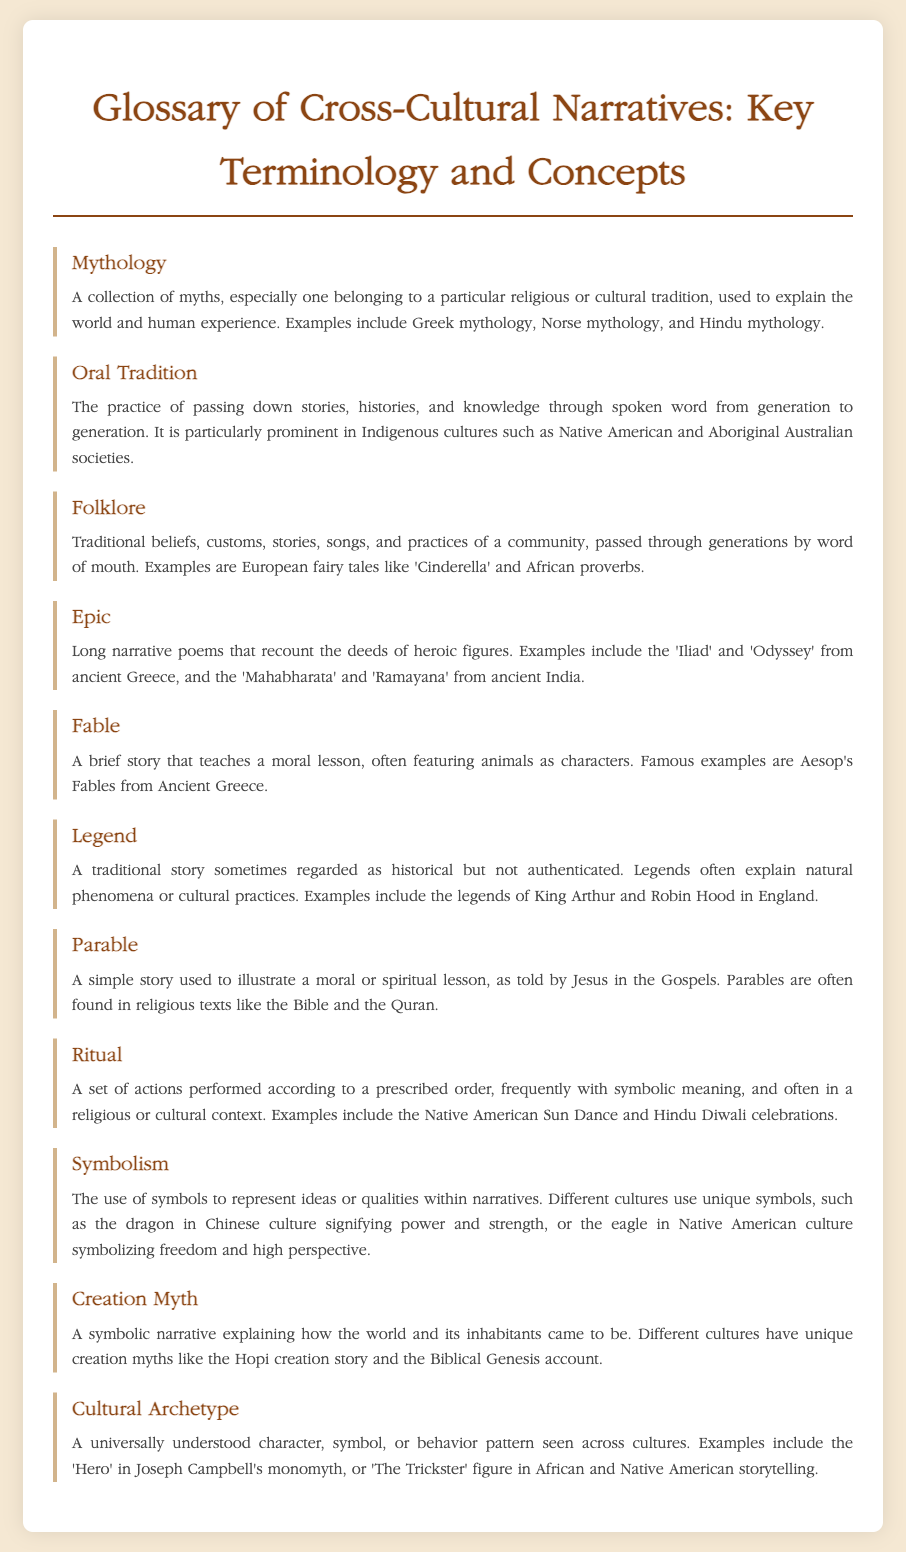What is a collection of myths? A collection of myths is used to explain the world and human experience, belonging to a particular religious or cultural tradition.
Answer: Mythology What practice involves passing down stories through spoken word? This practice is primarily seen in Indigenous cultures and involves oral storytelling from generation to generation.
Answer: Oral Tradition What are traditional beliefs and stories passed by word of mouth called? These are traditional beliefs, customs, stories, songs, and practices of a community that are shared orally.
Answer: Folklore Which narrative form features heroic figures and is often a long poem? This narrative form recounts the deeds of heroic figures through a long narrative format, often in poetic form.
Answer: Epic What type of story often features animals and teaches a moral lesson? This type of story is typically brief and aims to convey moral lessons through the actions of animals.
Answer: Fable What is a traditional story that may not be authenticated but explains cultural practices? This type of story is sometimes regarded as historical and often explains natural phenomena or cultural practices.
Answer: Legend What story format is used to illustrate a moral or spiritual lesson? This format is often found in religious texts and utilizes stories that simplify moral concepts.
Answer: Parable What is a set of actions with symbolic meaning performed in a cultural context? This refers to a customary practice that often has a deeper significance within a culture or religion.
Answer: Ritual What term refers to the use of symbols to represent ideas within narratives? This term describes how different cultures utilize symbols, such as animals or natural elements, to convey deeper meanings.
Answer: Symbolism What kind of narrative explains how the world and its inhabitants came to be? This narrative form often involves significant cultural stories that detail the origins of a culture or civilization.
Answer: Creation Myth 